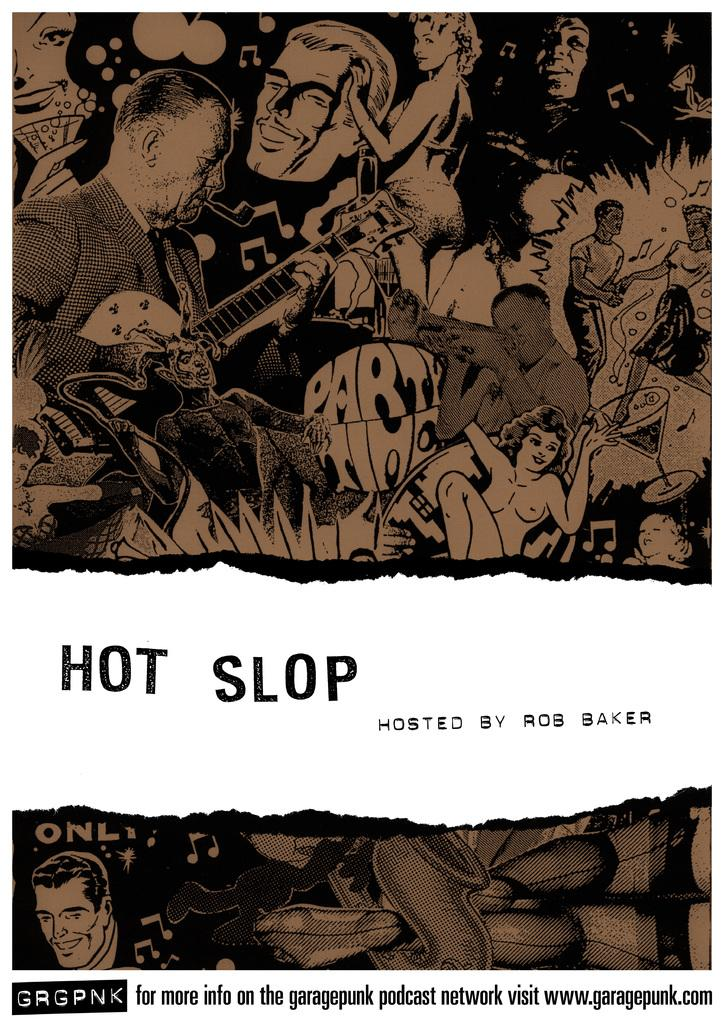What type of image is this? The image might be a poster. Can you describe the people in the image? There is a group of people in the image. What are some of the people doing in the image? Some of the people are holding musical instruments. What other elements are present in the image? There are music symbols and text in the image. What type of toothpaste is being advertised in the image? There is no toothpaste present in the image. How many sticks are visible in the image? There are no sticks visible in the image. 